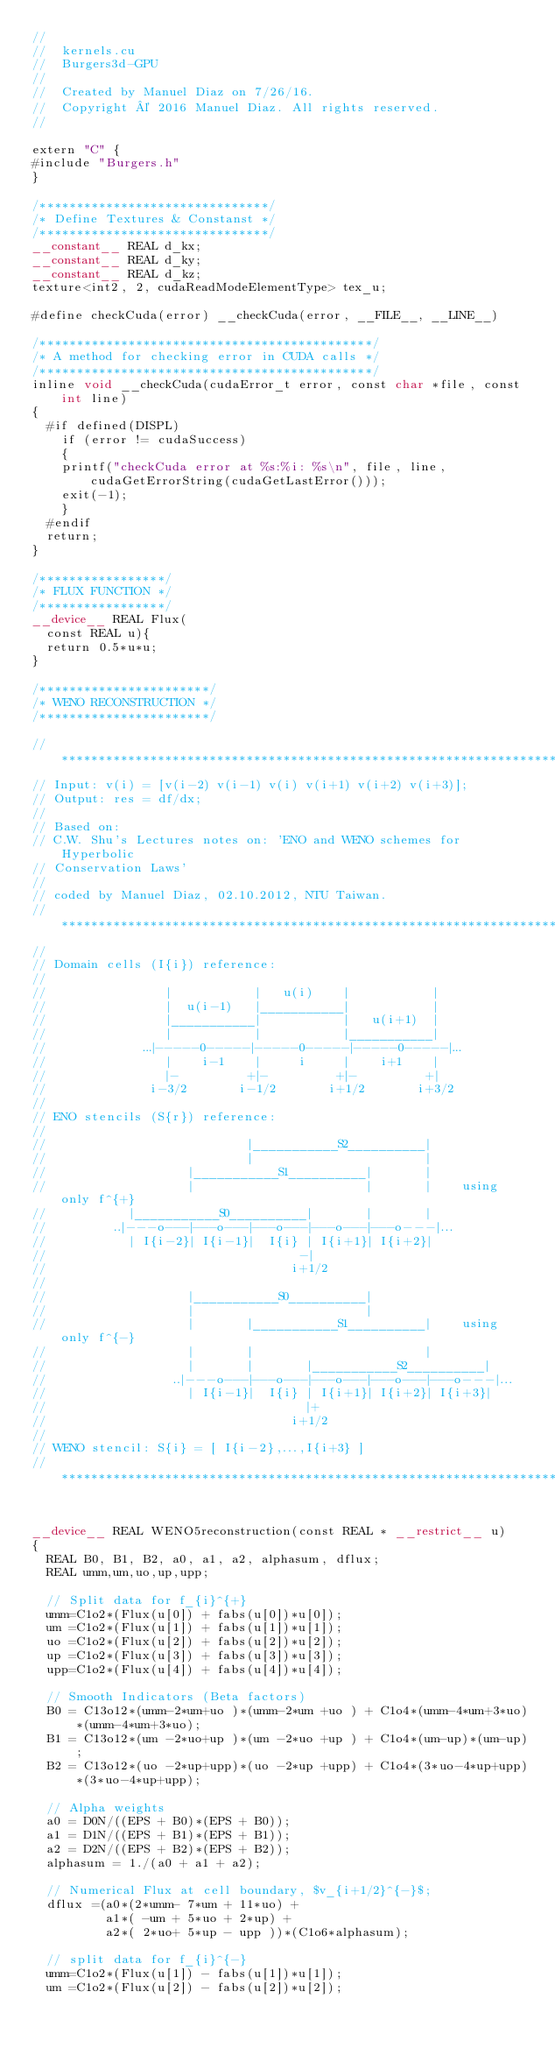Convert code to text. <code><loc_0><loc_0><loc_500><loc_500><_Cuda_>//
//  kernels.cu
//  Burgers3d-GPU
//
//  Created by Manuel Diaz on 7/26/16.
//  Copyright © 2016 Manuel Diaz. All rights reserved.
//

extern "C" {
#include "Burgers.h"
}

/*******************************/
/* Define Textures & Constanst */
/*******************************/
__constant__ REAL d_kx;
__constant__ REAL d_ky;
__constant__ REAL d_kz;
texture<int2, 2, cudaReadModeElementType> tex_u;

#define checkCuda(error) __checkCuda(error, __FILE__, __LINE__)

/*********************************************/
/* A method for checking error in CUDA calls */
/*********************************************/
inline void __checkCuda(cudaError_t error, const char *file, const int line)
{
  #if defined(DISPL)
    if (error != cudaSuccess)
    {
    printf("checkCuda error at %s:%i: %s\n", file, line, cudaGetErrorString(cudaGetLastError()));
    exit(-1);
    }
  #endif
  return;
}

/*****************/
/* FLUX FUNCTION */
/*****************/
__device__ REAL Flux(
  const REAL u){
  return 0.5*u*u;
}

/***********************/
/* WENO RECONSTRUCTION */
/***********************/

// *************************************************************************
// Input: v(i) = [v(i-2) v(i-1) v(i) v(i+1) v(i+2) v(i+3)];
// Output: res = df/dx;
//
// Based on:
// C.W. Shu's Lectures notes on: 'ENO and WENO schemes for Hyperbolic
// Conservation Laws'
//
// coded by Manuel Diaz, 02.10.2012, NTU Taiwan.
// *************************************************************************
//
// Domain cells (I{i}) reference:
//
//                |           |   u(i)    |           |
//                |  u(i-1)   |___________|           |
//                |___________|           |   u(i+1)  |
//                |           |           |___________|
//             ...|-----0-----|-----0-----|-----0-----|...
//                |    i-1    |     i     |    i+1    |
//                |-         +|-         +|-         +|
//              i-3/2       i-1/2       i+1/2       i+3/2
//
// ENO stencils (S{r}) reference:
//
//                           |___________S2__________|
//                           |                       |
//                   |___________S1__________|       |
//                   |                       |       |    using only f^{+}
//           |___________S0__________|       |       |
//         ..|---o---|---o---|---o---|---o---|---o---|...
//           | I{i-2}| I{i-1}|  I{i} | I{i+1}| I{i+2}|
//                                  -|
//                                 i+1/2
//
//                   |___________S0__________|
//                   |                       |
//                   |       |___________S1__________|    using only f^{-}
//                   |       |                       |
//                   |       |       |___________S2__________|
//                 ..|---o---|---o---|---o---|---o---|---o---|...
//                   | I{i-1}|  I{i} | I{i+1}| I{i+2}| I{i+3}|
//                                   |+
//                                 i+1/2
//
// WENO stencil: S{i} = [ I{i-2},...,I{i+3} ]
// *************************************************************************


__device__ REAL WENO5reconstruction(const REAL * __restrict__ u)
{
  REAL B0, B1, B2, a0, a1, a2, alphasum, dflux;
  REAL umm,um,uo,up,upp;

  // Split data for f_{i}^{+}
  umm=C1o2*(Flux(u[0]) + fabs(u[0])*u[0]);
  um =C1o2*(Flux(u[1]) + fabs(u[1])*u[1]);
  uo =C1o2*(Flux(u[2]) + fabs(u[2])*u[2]);
  up =C1o2*(Flux(u[3]) + fabs(u[3])*u[3]);
  upp=C1o2*(Flux(u[4]) + fabs(u[4])*u[4]);
  
  // Smooth Indicators (Beta factors)
  B0 = C13o12*(umm-2*um+uo )*(umm-2*um +uo ) + C1o4*(umm-4*um+3*uo)*(umm-4*um+3*uo);
  B1 = C13o12*(um -2*uo+up )*(um -2*uo +up ) + C1o4*(um-up)*(um-up);
  B2 = C13o12*(uo -2*up+upp)*(uo -2*up +upp) + C1o4*(3*uo-4*up+upp)*(3*uo-4*up+upp);
  
  // Alpha weights
  a0 = D0N/((EPS + B0)*(EPS + B0));
  a1 = D1N/((EPS + B1)*(EPS + B1));
  a2 = D2N/((EPS + B2)*(EPS + B2));
  alphasum = 1./(a0 + a1 + a2);
  
  // Numerical Flux at cell boundary, $v_{i+1/2}^{-}$;
  dflux =(a0*(2*umm- 7*um + 11*uo) +
          a1*( -um + 5*uo + 2*up) +
          a2*( 2*uo+ 5*up - upp ))*(C1o6*alphasum);

  // split data for f_{i}^{-}
  umm=C1o2*(Flux(u[1]) - fabs(u[1])*u[1]);
  um =C1o2*(Flux(u[2]) - fabs(u[2])*u[2]);</code> 